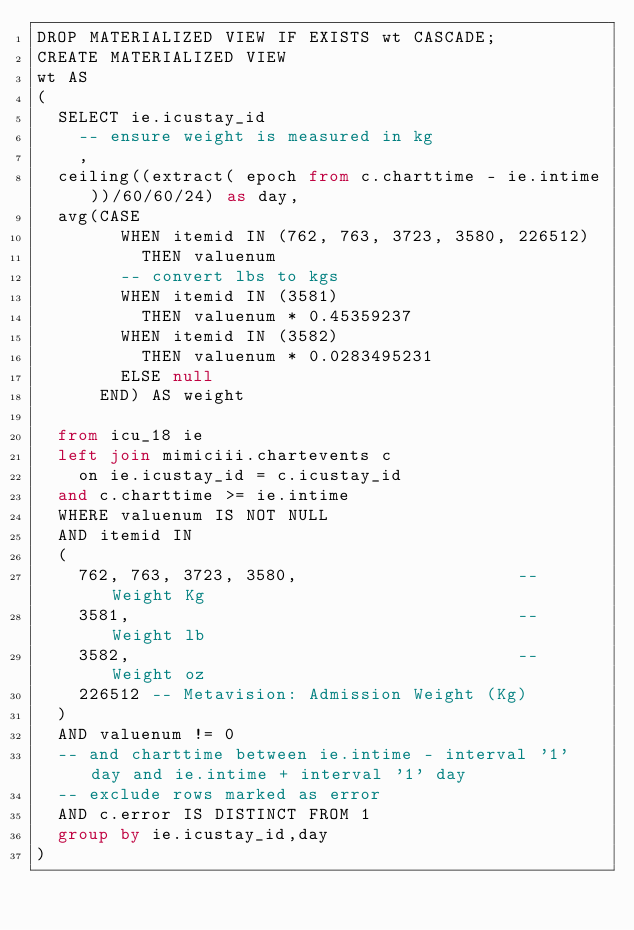Convert code to text. <code><loc_0><loc_0><loc_500><loc_500><_SQL_>DROP MATERIALIZED VIEW IF EXISTS wt CASCADE;
CREATE MATERIALIZED VIEW 
wt AS
(
  SELECT ie.icustay_id
    -- ensure weight is measured in kg
    , 
	ceiling((extract( epoch from c.charttime - ie.intime))/60/60/24) as day,
	avg(CASE
        WHEN itemid IN (762, 763, 3723, 3580, 226512)
          THEN valuenum
        -- convert lbs to kgs
        WHEN itemid IN (3581)
          THEN valuenum * 0.45359237
        WHEN itemid IN (3582)
          THEN valuenum * 0.0283495231
        ELSE null
      END) AS weight

  from icu_18 ie
  left join mimiciii.chartevents c
    on ie.icustay_id = c.icustay_id
	and c.charttime >= ie.intime
  WHERE valuenum IS NOT NULL
  AND itemid IN
  (
    762, 763, 3723, 3580,                     -- Weight Kg
    3581,                                     -- Weight lb
    3582,                                     -- Weight oz
    226512 -- Metavision: Admission Weight (Kg)
  )
  AND valuenum != 0
  -- and charttime between ie.intime - interval '1' day and ie.intime + interval '1' day
  -- exclude rows marked as error
  AND c.error IS DISTINCT FROM 1
  group by ie.icustay_id,day
)</code> 